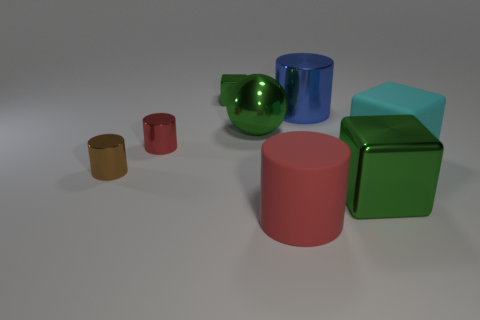Add 2 big blue objects. How many objects exist? 10 Subtract all balls. How many objects are left? 7 Add 1 blue shiny cylinders. How many blue shiny cylinders exist? 2 Subtract 0 red balls. How many objects are left? 8 Subtract all purple matte cubes. Subtract all big blue shiny cylinders. How many objects are left? 7 Add 4 green balls. How many green balls are left? 5 